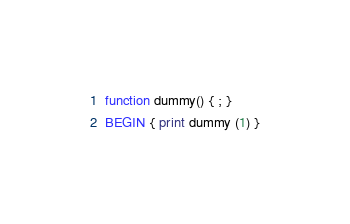Convert code to text. <code><loc_0><loc_0><loc_500><loc_500><_Awk_>function dummy() { ; }
BEGIN { print dummy (1) }
</code> 